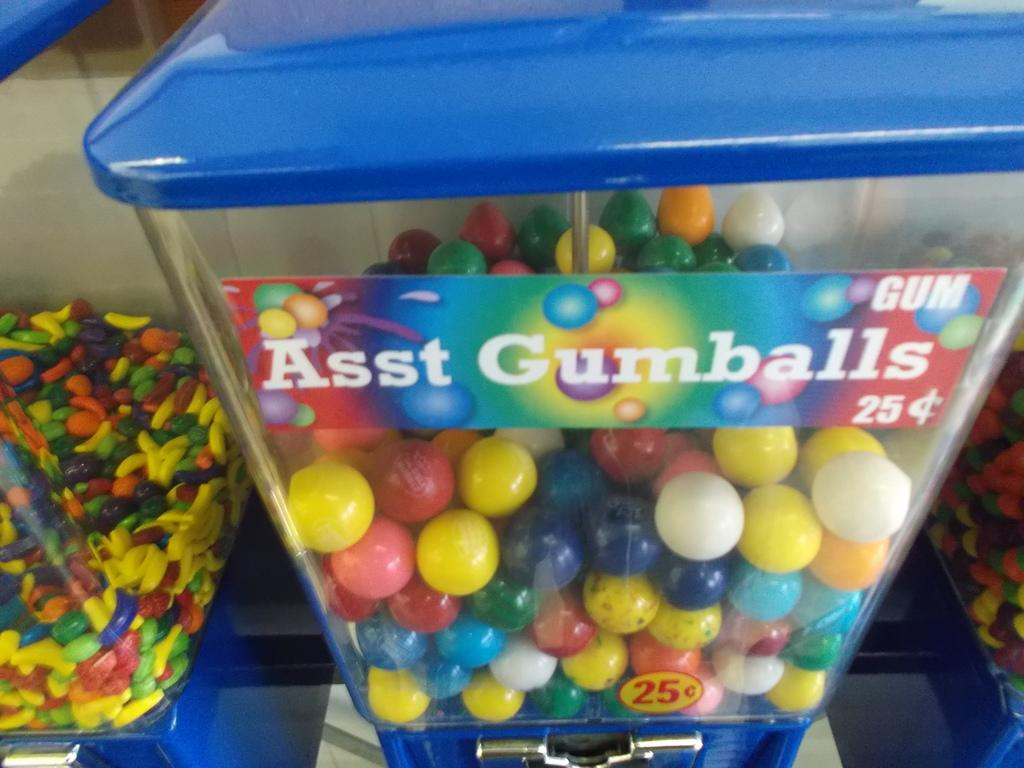What objects are present in the image that hold items? There are containers in the image. What type of items are being held by the containers? The containers hold groups of candies. What type of texture can be seen on the stone in the image? There is no stone present in the image; it features containers holding groups of candies. What type of writing is visible on the candies in the image? The provided facts do not mention any writing on the candies, so we cannot determine if there is any writing present. 